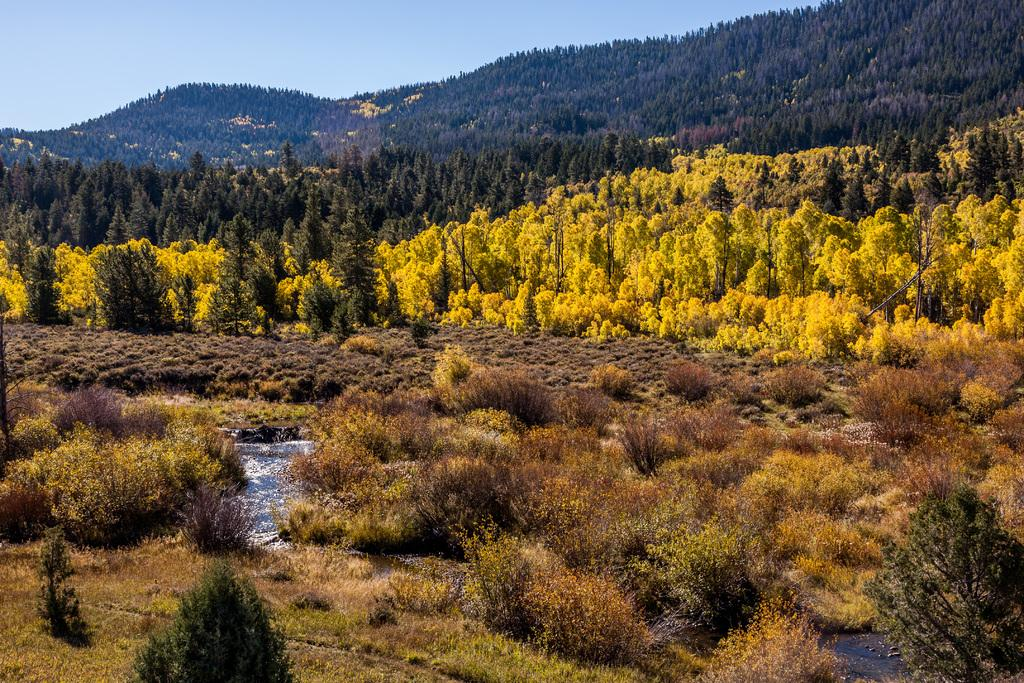What type of vegetation can be seen in the image? There are trees in the image. What is the ground covered with in the image? There is grass in the image. What natural feature is visible in the image? There is water visible in the image. What type of landscape can be seen in the image? There are hills in the image. What is visible above the landscape in the image? The sky is visible in the image. How many pigs are causing trouble with the babies in the image? There are no pigs or babies present in the image. 